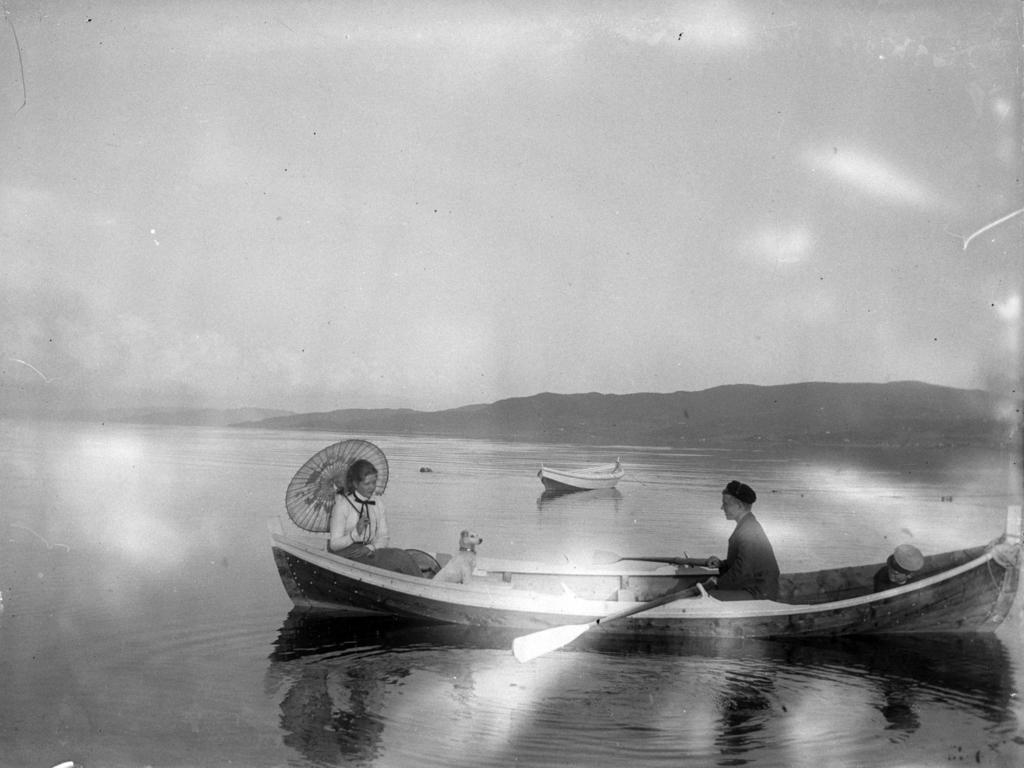What is happening on the water in the image? There are boats on the water in the image. How many people are on one of the boats? There are two people on one of the boats. What type of animal is also on the boat with the people? There is a dog on the boat with the people. What is the boat with the people using for propulsion? The boat with the people has a paddle. What is the boat with the people using for shade? The boat with the people has an umbrella. What can be seen in the distance in the image? There are mountains visible in the background of the image. What else is visible in the background of the image? The sky is visible in the background of the image. Where is the calendar hanging on the boat in the image? There is no calendar present in the image. What type of beef is being served on the boat in the image? There is no beef present in the image. 